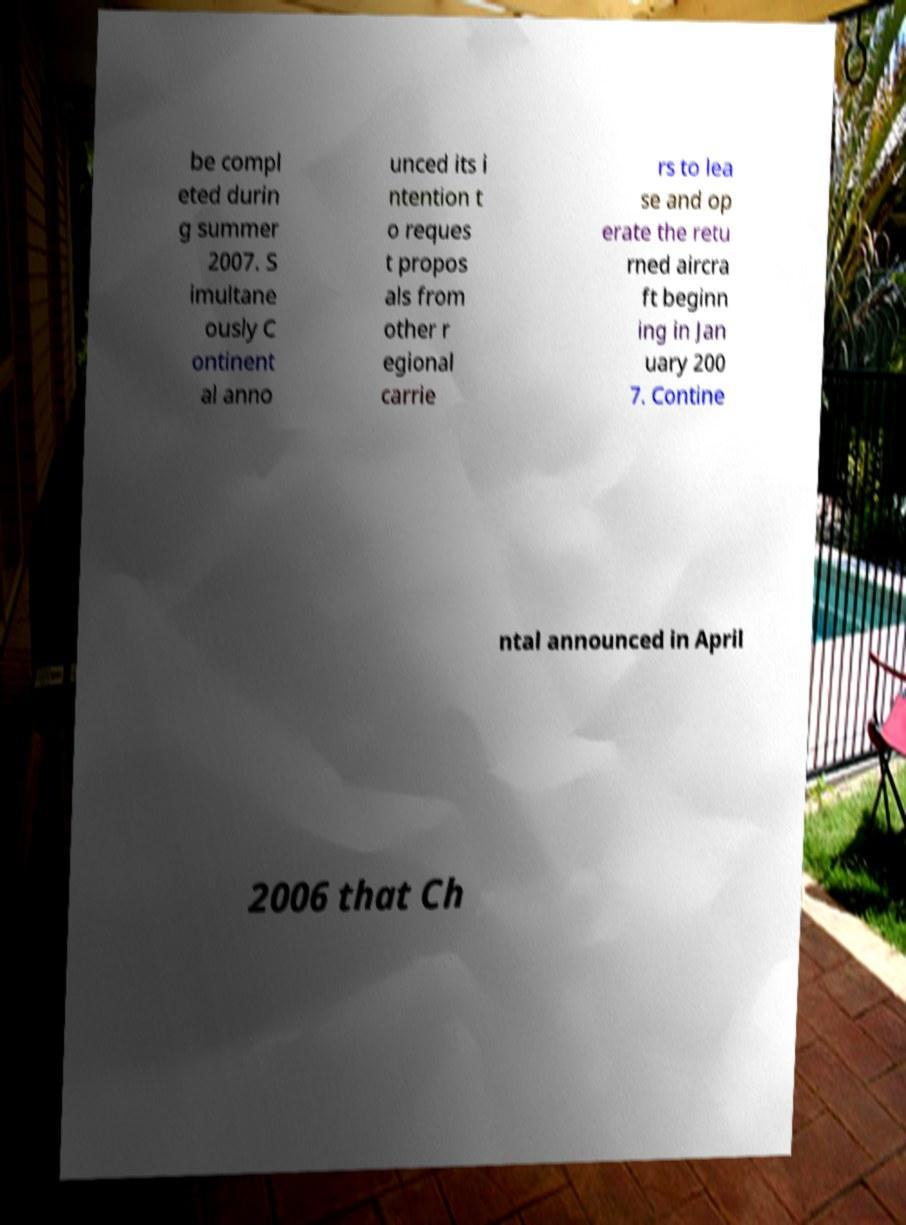Please identify and transcribe the text found in this image. be compl eted durin g summer 2007. S imultane ously C ontinent al anno unced its i ntention t o reques t propos als from other r egional carrie rs to lea se and op erate the retu rned aircra ft beginn ing in Jan uary 200 7. Contine ntal announced in April 2006 that Ch 